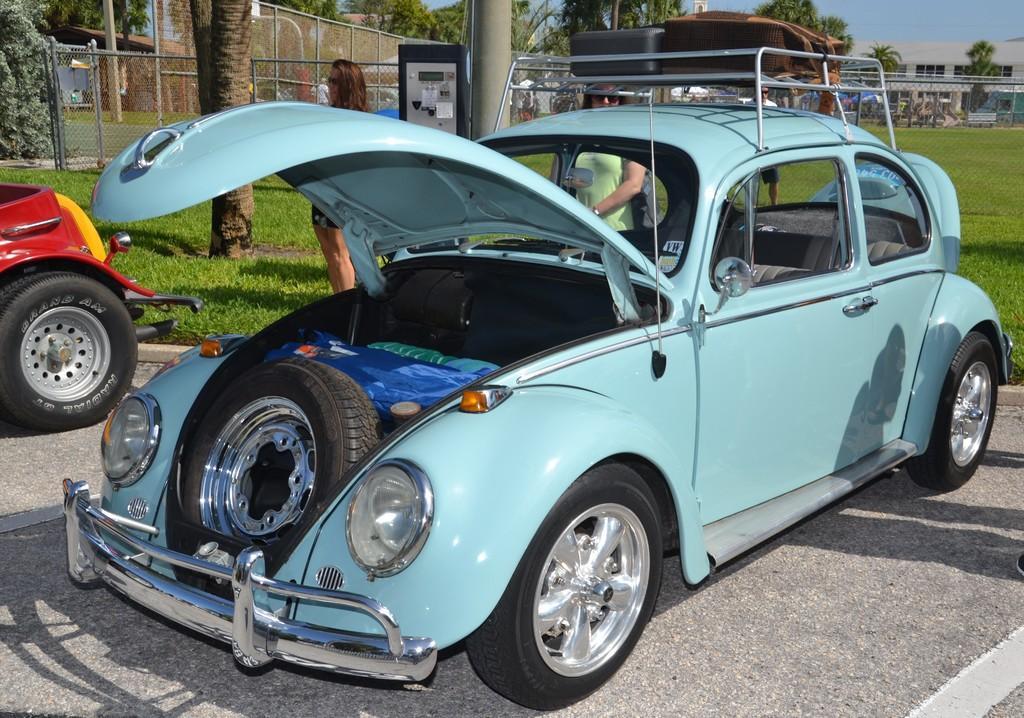Could you give a brief overview of what you see in this image? In this picture we can see two vehicles parked on the road. Behind the vehicles, there are people, buildings, grass, fencing and trees. Behind the trees, there is the sky. 